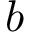Convert formula to latex. <formula><loc_0><loc_0><loc_500><loc_500>b</formula> 